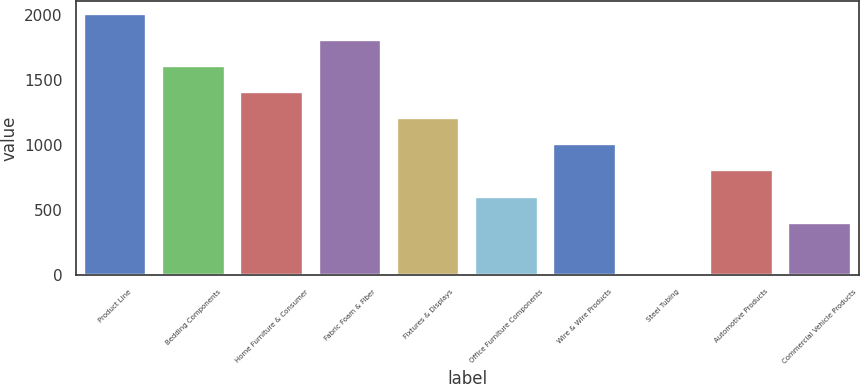Convert chart. <chart><loc_0><loc_0><loc_500><loc_500><bar_chart><fcel>Product Line<fcel>Bedding Components<fcel>Home Furniture & Consumer<fcel>Fabric Foam & Fiber<fcel>Fixtures & Displays<fcel>Office Furniture Components<fcel>Wire & Wire Products<fcel>Steel Tubing<fcel>Automotive Products<fcel>Commercial Vehicle Products<nl><fcel>2007<fcel>1606<fcel>1405.5<fcel>1806.5<fcel>1205<fcel>603.5<fcel>1004.5<fcel>2<fcel>804<fcel>403<nl></chart> 